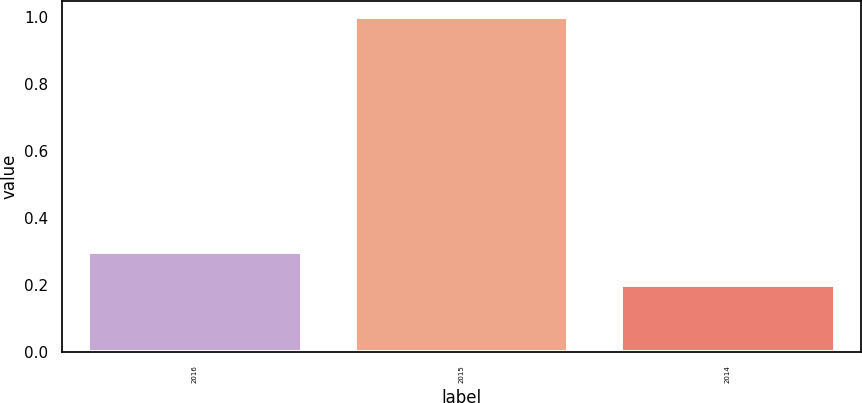<chart> <loc_0><loc_0><loc_500><loc_500><bar_chart><fcel>2016<fcel>2015<fcel>2014<nl><fcel>0.3<fcel>1<fcel>0.2<nl></chart> 